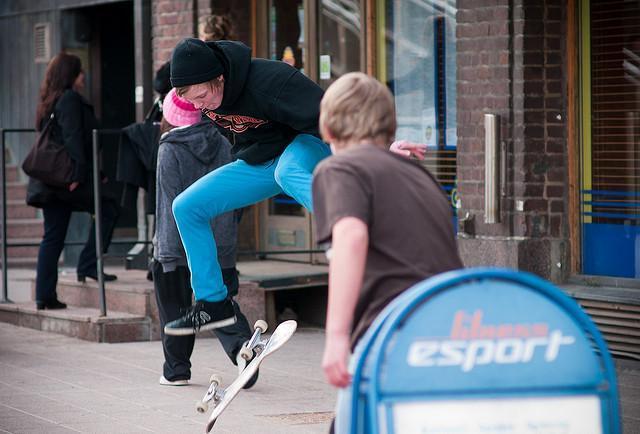How many people are in the photo?
Give a very brief answer. 4. How many skateboards can be seen?
Give a very brief answer. 1. 